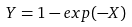Convert formula to latex. <formula><loc_0><loc_0><loc_500><loc_500>Y = 1 - e x p ( - X )</formula> 